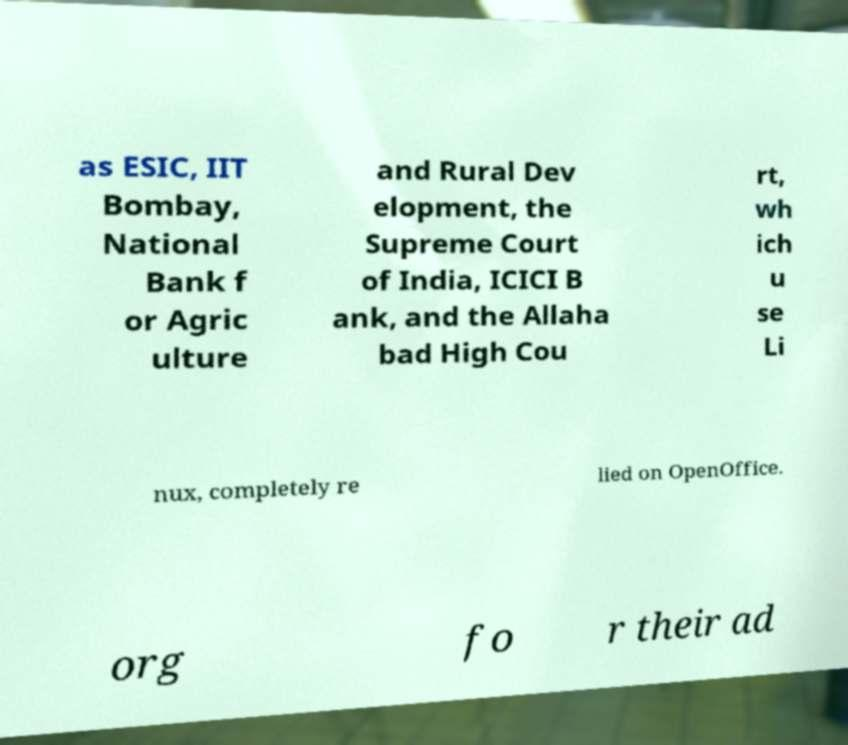Can you read and provide the text displayed in the image?This photo seems to have some interesting text. Can you extract and type it out for me? as ESIC, IIT Bombay, National Bank f or Agric ulture and Rural Dev elopment, the Supreme Court of India, ICICI B ank, and the Allaha bad High Cou rt, wh ich u se Li nux, completely re lied on OpenOffice. org fo r their ad 